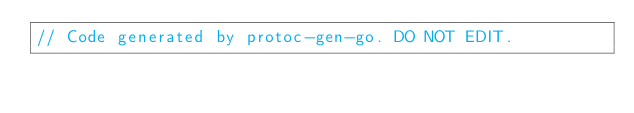Convert code to text. <code><loc_0><loc_0><loc_500><loc_500><_Go_>// Code generated by protoc-gen-go. DO NOT EDIT.</code> 